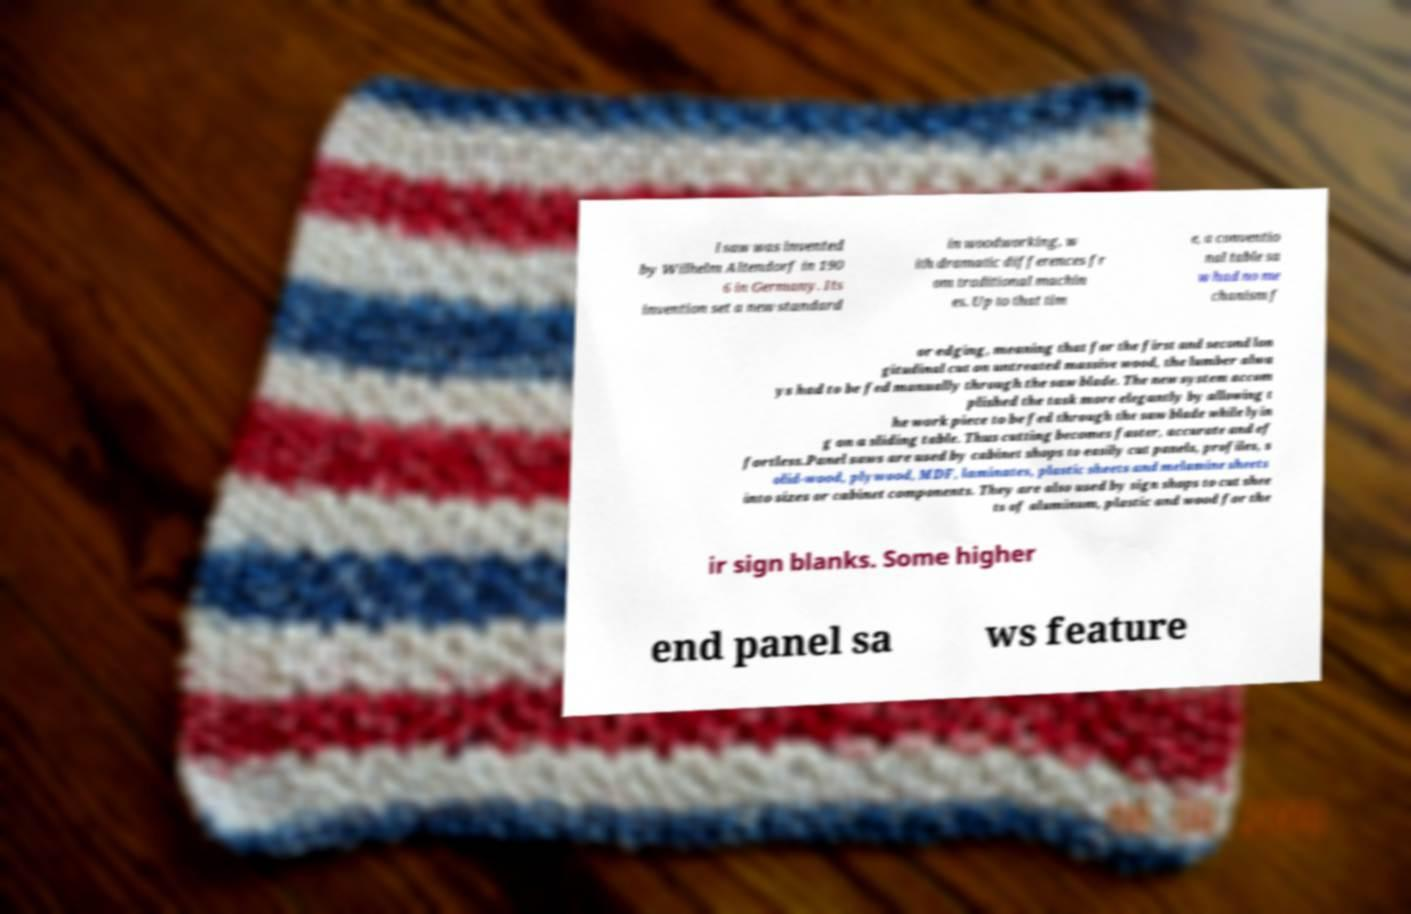Can you accurately transcribe the text from the provided image for me? l saw was invented by Wilhelm Altendorf in 190 6 in Germany. Its invention set a new standard in woodworking, w ith dramatic differences fr om traditional machin es. Up to that tim e, a conventio nal table sa w had no me chanism f or edging, meaning that for the first and second lon gitudinal cut on untreated massive wood, the lumber alwa ys had to be fed manually through the saw blade. The new system accom plished the task more elegantly by allowing t he work piece to be fed through the saw blade while lyin g on a sliding table. Thus cutting becomes faster, accurate and ef fortless.Panel saws are used by cabinet shops to easily cut panels, profiles, s olid-wood, plywood, MDF, laminates, plastic sheets and melamine sheets into sizes or cabinet components. They are also used by sign shops to cut shee ts of aluminum, plastic and wood for the ir sign blanks. Some higher end panel sa ws feature 